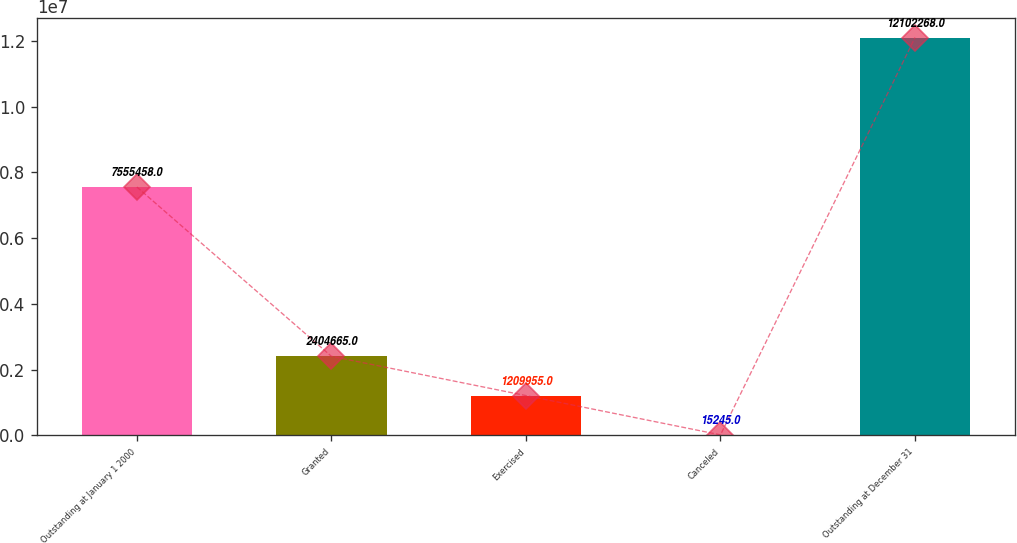<chart> <loc_0><loc_0><loc_500><loc_500><bar_chart><fcel>Outstanding at January 1 2000<fcel>Granted<fcel>Exercised<fcel>Canceled<fcel>Outstanding at December 31<nl><fcel>7.55546e+06<fcel>2.40466e+06<fcel>1.20996e+06<fcel>15245<fcel>1.21023e+07<nl></chart> 